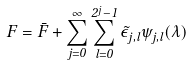Convert formula to latex. <formula><loc_0><loc_0><loc_500><loc_500>F = \bar { F } + \sum _ { j = 0 } ^ { \infty } \sum _ { l = 0 } ^ { 2 ^ { j } - 1 } \tilde { \epsilon } _ { j , l } \psi _ { j , l } ( \lambda )</formula> 